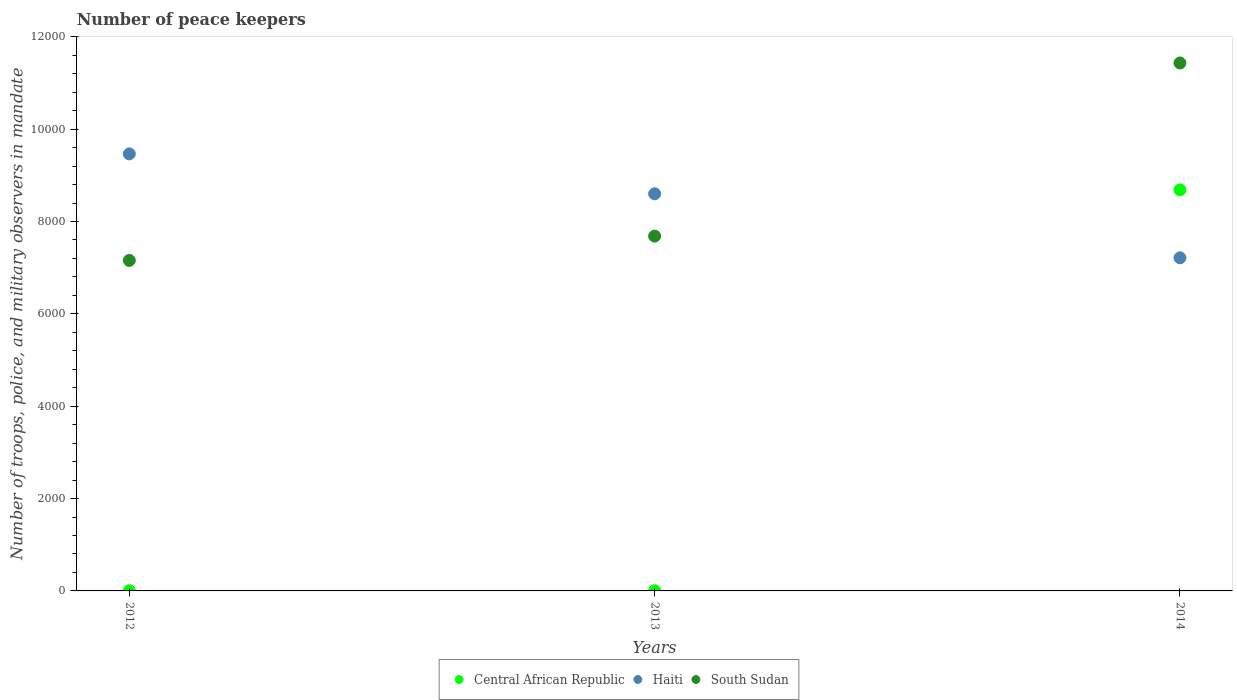What is the number of peace keepers in in South Sudan in 2013?
Your response must be concise. 7684. Across all years, what is the maximum number of peace keepers in in Central African Republic?
Ensure brevity in your answer.  8685. Across all years, what is the minimum number of peace keepers in in Central African Republic?
Provide a succinct answer. 4. In which year was the number of peace keepers in in South Sudan minimum?
Your response must be concise. 2012. What is the total number of peace keepers in in Central African Republic in the graph?
Offer a very short reply. 8693. What is the difference between the number of peace keepers in in Haiti in 2012 and that in 2013?
Your response must be concise. 864. What is the difference between the number of peace keepers in in Haiti in 2013 and the number of peace keepers in in Central African Republic in 2012?
Keep it short and to the point. 8596. What is the average number of peace keepers in in South Sudan per year?
Offer a very short reply. 8758. In the year 2012, what is the difference between the number of peace keepers in in Haiti and number of peace keepers in in Central African Republic?
Offer a terse response. 9460. What is the ratio of the number of peace keepers in in South Sudan in 2012 to that in 2013?
Your answer should be compact. 0.93. Is the number of peace keepers in in South Sudan in 2012 less than that in 2014?
Give a very brief answer. Yes. What is the difference between the highest and the second highest number of peace keepers in in South Sudan?
Provide a short and direct response. 3749. What is the difference between the highest and the lowest number of peace keepers in in South Sudan?
Offer a very short reply. 4276. In how many years, is the number of peace keepers in in Haiti greater than the average number of peace keepers in in Haiti taken over all years?
Keep it short and to the point. 2. Is the sum of the number of peace keepers in in South Sudan in 2012 and 2014 greater than the maximum number of peace keepers in in Haiti across all years?
Your response must be concise. Yes. Is the number of peace keepers in in South Sudan strictly less than the number of peace keepers in in Central African Republic over the years?
Keep it short and to the point. No. How many dotlines are there?
Your answer should be compact. 3. What is the difference between two consecutive major ticks on the Y-axis?
Make the answer very short. 2000. Are the values on the major ticks of Y-axis written in scientific E-notation?
Keep it short and to the point. No. Does the graph contain grids?
Ensure brevity in your answer.  No. How many legend labels are there?
Your answer should be compact. 3. What is the title of the graph?
Provide a succinct answer. Number of peace keepers. What is the label or title of the X-axis?
Your answer should be compact. Years. What is the label or title of the Y-axis?
Offer a terse response. Number of troops, police, and military observers in mandate. What is the Number of troops, police, and military observers in mandate of Haiti in 2012?
Offer a very short reply. 9464. What is the Number of troops, police, and military observers in mandate of South Sudan in 2012?
Provide a succinct answer. 7157. What is the Number of troops, police, and military observers in mandate in Central African Republic in 2013?
Provide a succinct answer. 4. What is the Number of troops, police, and military observers in mandate in Haiti in 2013?
Provide a short and direct response. 8600. What is the Number of troops, police, and military observers in mandate of South Sudan in 2013?
Your response must be concise. 7684. What is the Number of troops, police, and military observers in mandate of Central African Republic in 2014?
Give a very brief answer. 8685. What is the Number of troops, police, and military observers in mandate in Haiti in 2014?
Offer a very short reply. 7213. What is the Number of troops, police, and military observers in mandate of South Sudan in 2014?
Ensure brevity in your answer.  1.14e+04. Across all years, what is the maximum Number of troops, police, and military observers in mandate in Central African Republic?
Your answer should be compact. 8685. Across all years, what is the maximum Number of troops, police, and military observers in mandate in Haiti?
Your answer should be compact. 9464. Across all years, what is the maximum Number of troops, police, and military observers in mandate of South Sudan?
Make the answer very short. 1.14e+04. Across all years, what is the minimum Number of troops, police, and military observers in mandate of Central African Republic?
Offer a very short reply. 4. Across all years, what is the minimum Number of troops, police, and military observers in mandate in Haiti?
Offer a very short reply. 7213. Across all years, what is the minimum Number of troops, police, and military observers in mandate of South Sudan?
Keep it short and to the point. 7157. What is the total Number of troops, police, and military observers in mandate of Central African Republic in the graph?
Ensure brevity in your answer.  8693. What is the total Number of troops, police, and military observers in mandate of Haiti in the graph?
Keep it short and to the point. 2.53e+04. What is the total Number of troops, police, and military observers in mandate in South Sudan in the graph?
Your answer should be compact. 2.63e+04. What is the difference between the Number of troops, police, and military observers in mandate in Haiti in 2012 and that in 2013?
Give a very brief answer. 864. What is the difference between the Number of troops, police, and military observers in mandate in South Sudan in 2012 and that in 2013?
Offer a terse response. -527. What is the difference between the Number of troops, police, and military observers in mandate in Central African Republic in 2012 and that in 2014?
Your answer should be compact. -8681. What is the difference between the Number of troops, police, and military observers in mandate in Haiti in 2012 and that in 2014?
Make the answer very short. 2251. What is the difference between the Number of troops, police, and military observers in mandate of South Sudan in 2012 and that in 2014?
Your answer should be compact. -4276. What is the difference between the Number of troops, police, and military observers in mandate in Central African Republic in 2013 and that in 2014?
Give a very brief answer. -8681. What is the difference between the Number of troops, police, and military observers in mandate in Haiti in 2013 and that in 2014?
Keep it short and to the point. 1387. What is the difference between the Number of troops, police, and military observers in mandate in South Sudan in 2013 and that in 2014?
Provide a short and direct response. -3749. What is the difference between the Number of troops, police, and military observers in mandate of Central African Republic in 2012 and the Number of troops, police, and military observers in mandate of Haiti in 2013?
Keep it short and to the point. -8596. What is the difference between the Number of troops, police, and military observers in mandate of Central African Republic in 2012 and the Number of troops, police, and military observers in mandate of South Sudan in 2013?
Make the answer very short. -7680. What is the difference between the Number of troops, police, and military observers in mandate of Haiti in 2012 and the Number of troops, police, and military observers in mandate of South Sudan in 2013?
Keep it short and to the point. 1780. What is the difference between the Number of troops, police, and military observers in mandate in Central African Republic in 2012 and the Number of troops, police, and military observers in mandate in Haiti in 2014?
Make the answer very short. -7209. What is the difference between the Number of troops, police, and military observers in mandate of Central African Republic in 2012 and the Number of troops, police, and military observers in mandate of South Sudan in 2014?
Make the answer very short. -1.14e+04. What is the difference between the Number of troops, police, and military observers in mandate in Haiti in 2012 and the Number of troops, police, and military observers in mandate in South Sudan in 2014?
Your response must be concise. -1969. What is the difference between the Number of troops, police, and military observers in mandate of Central African Republic in 2013 and the Number of troops, police, and military observers in mandate of Haiti in 2014?
Your response must be concise. -7209. What is the difference between the Number of troops, police, and military observers in mandate of Central African Republic in 2013 and the Number of troops, police, and military observers in mandate of South Sudan in 2014?
Make the answer very short. -1.14e+04. What is the difference between the Number of troops, police, and military observers in mandate in Haiti in 2013 and the Number of troops, police, and military observers in mandate in South Sudan in 2014?
Keep it short and to the point. -2833. What is the average Number of troops, police, and military observers in mandate of Central African Republic per year?
Offer a terse response. 2897.67. What is the average Number of troops, police, and military observers in mandate of Haiti per year?
Offer a very short reply. 8425.67. What is the average Number of troops, police, and military observers in mandate in South Sudan per year?
Your answer should be compact. 8758. In the year 2012, what is the difference between the Number of troops, police, and military observers in mandate of Central African Republic and Number of troops, police, and military observers in mandate of Haiti?
Give a very brief answer. -9460. In the year 2012, what is the difference between the Number of troops, police, and military observers in mandate of Central African Republic and Number of troops, police, and military observers in mandate of South Sudan?
Your answer should be compact. -7153. In the year 2012, what is the difference between the Number of troops, police, and military observers in mandate in Haiti and Number of troops, police, and military observers in mandate in South Sudan?
Offer a very short reply. 2307. In the year 2013, what is the difference between the Number of troops, police, and military observers in mandate of Central African Republic and Number of troops, police, and military observers in mandate of Haiti?
Provide a succinct answer. -8596. In the year 2013, what is the difference between the Number of troops, police, and military observers in mandate in Central African Republic and Number of troops, police, and military observers in mandate in South Sudan?
Keep it short and to the point. -7680. In the year 2013, what is the difference between the Number of troops, police, and military observers in mandate in Haiti and Number of troops, police, and military observers in mandate in South Sudan?
Your answer should be compact. 916. In the year 2014, what is the difference between the Number of troops, police, and military observers in mandate of Central African Republic and Number of troops, police, and military observers in mandate of Haiti?
Give a very brief answer. 1472. In the year 2014, what is the difference between the Number of troops, police, and military observers in mandate of Central African Republic and Number of troops, police, and military observers in mandate of South Sudan?
Ensure brevity in your answer.  -2748. In the year 2014, what is the difference between the Number of troops, police, and military observers in mandate in Haiti and Number of troops, police, and military observers in mandate in South Sudan?
Your answer should be very brief. -4220. What is the ratio of the Number of troops, police, and military observers in mandate of Haiti in 2012 to that in 2013?
Make the answer very short. 1.1. What is the ratio of the Number of troops, police, and military observers in mandate in South Sudan in 2012 to that in 2013?
Provide a succinct answer. 0.93. What is the ratio of the Number of troops, police, and military observers in mandate of Haiti in 2012 to that in 2014?
Ensure brevity in your answer.  1.31. What is the ratio of the Number of troops, police, and military observers in mandate of South Sudan in 2012 to that in 2014?
Make the answer very short. 0.63. What is the ratio of the Number of troops, police, and military observers in mandate in Central African Republic in 2013 to that in 2014?
Keep it short and to the point. 0. What is the ratio of the Number of troops, police, and military observers in mandate in Haiti in 2013 to that in 2014?
Make the answer very short. 1.19. What is the ratio of the Number of troops, police, and military observers in mandate of South Sudan in 2013 to that in 2014?
Your answer should be compact. 0.67. What is the difference between the highest and the second highest Number of troops, police, and military observers in mandate in Central African Republic?
Make the answer very short. 8681. What is the difference between the highest and the second highest Number of troops, police, and military observers in mandate in Haiti?
Give a very brief answer. 864. What is the difference between the highest and the second highest Number of troops, police, and military observers in mandate of South Sudan?
Your answer should be very brief. 3749. What is the difference between the highest and the lowest Number of troops, police, and military observers in mandate of Central African Republic?
Offer a terse response. 8681. What is the difference between the highest and the lowest Number of troops, police, and military observers in mandate in Haiti?
Your response must be concise. 2251. What is the difference between the highest and the lowest Number of troops, police, and military observers in mandate in South Sudan?
Offer a very short reply. 4276. 